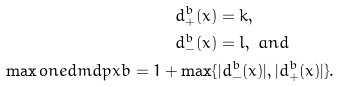<formula> <loc_0><loc_0><loc_500><loc_500>d _ { + } ^ { b } ( x ) & = k , \\ d _ { - } ^ { b } ( x ) & = l , \ a n d \\ \max o n e d m d p { x } { b } = 1 + \max \{ & | d _ { - } ^ { b } ( x ) | , | d _ { + } ^ { b } ( x ) | \} .</formula> 